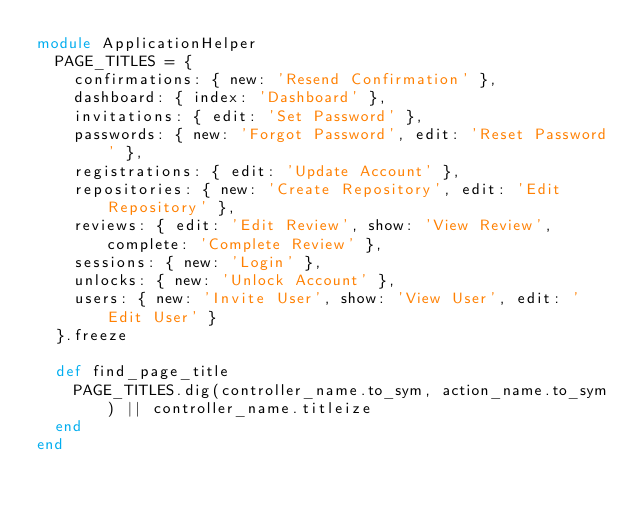<code> <loc_0><loc_0><loc_500><loc_500><_Ruby_>module ApplicationHelper
  PAGE_TITLES = {
    confirmations: { new: 'Resend Confirmation' },
    dashboard: { index: 'Dashboard' },
    invitations: { edit: 'Set Password' },
    passwords: { new: 'Forgot Password', edit: 'Reset Password' },
    registrations: { edit: 'Update Account' },
    repositories: { new: 'Create Repository', edit: 'Edit Repository' },
    reviews: { edit: 'Edit Review', show: 'View Review', complete: 'Complete Review' },
    sessions: { new: 'Login' },
    unlocks: { new: 'Unlock Account' },
    users: { new: 'Invite User', show: 'View User', edit: 'Edit User' }
  }.freeze

  def find_page_title
    PAGE_TITLES.dig(controller_name.to_sym, action_name.to_sym) || controller_name.titleize
  end
end
</code> 